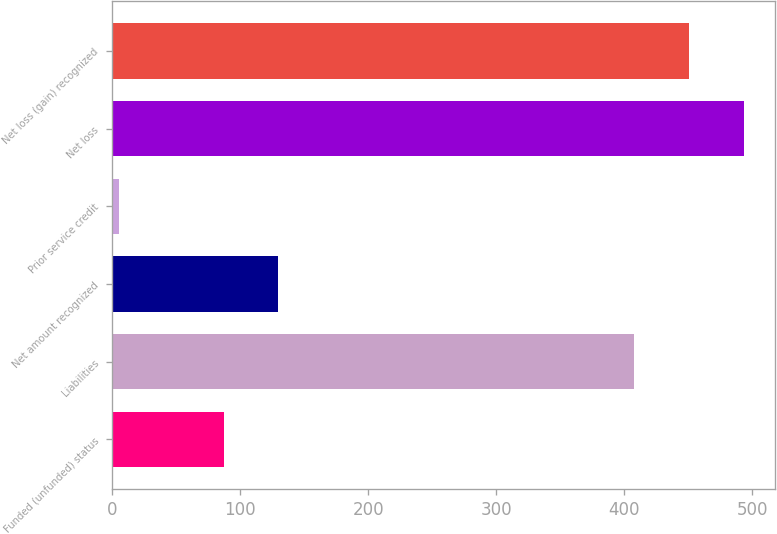<chart> <loc_0><loc_0><loc_500><loc_500><bar_chart><fcel>Funded (unfunded) status<fcel>Liabilities<fcel>Net amount recognized<fcel>Prior service credit<fcel>Net loss<fcel>Net loss (gain) recognized<nl><fcel>87<fcel>408<fcel>129.7<fcel>5<fcel>493.4<fcel>450.7<nl></chart> 